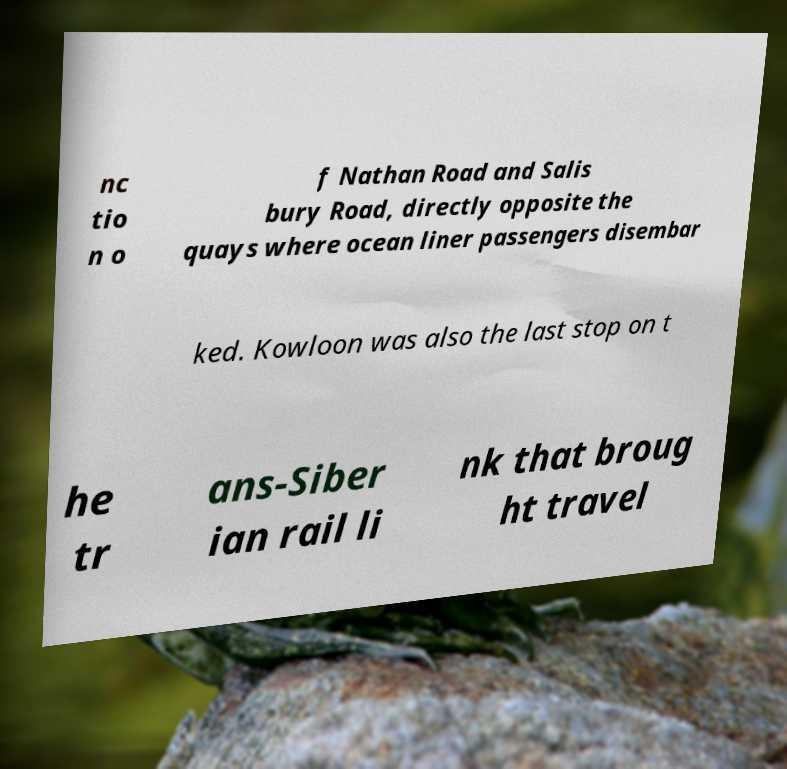Please read and relay the text visible in this image. What does it say? nc tio n o f Nathan Road and Salis bury Road, directly opposite the quays where ocean liner passengers disembar ked. Kowloon was also the last stop on t he tr ans-Siber ian rail li nk that broug ht travel 